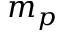Convert formula to latex. <formula><loc_0><loc_0><loc_500><loc_500>m _ { p }</formula> 